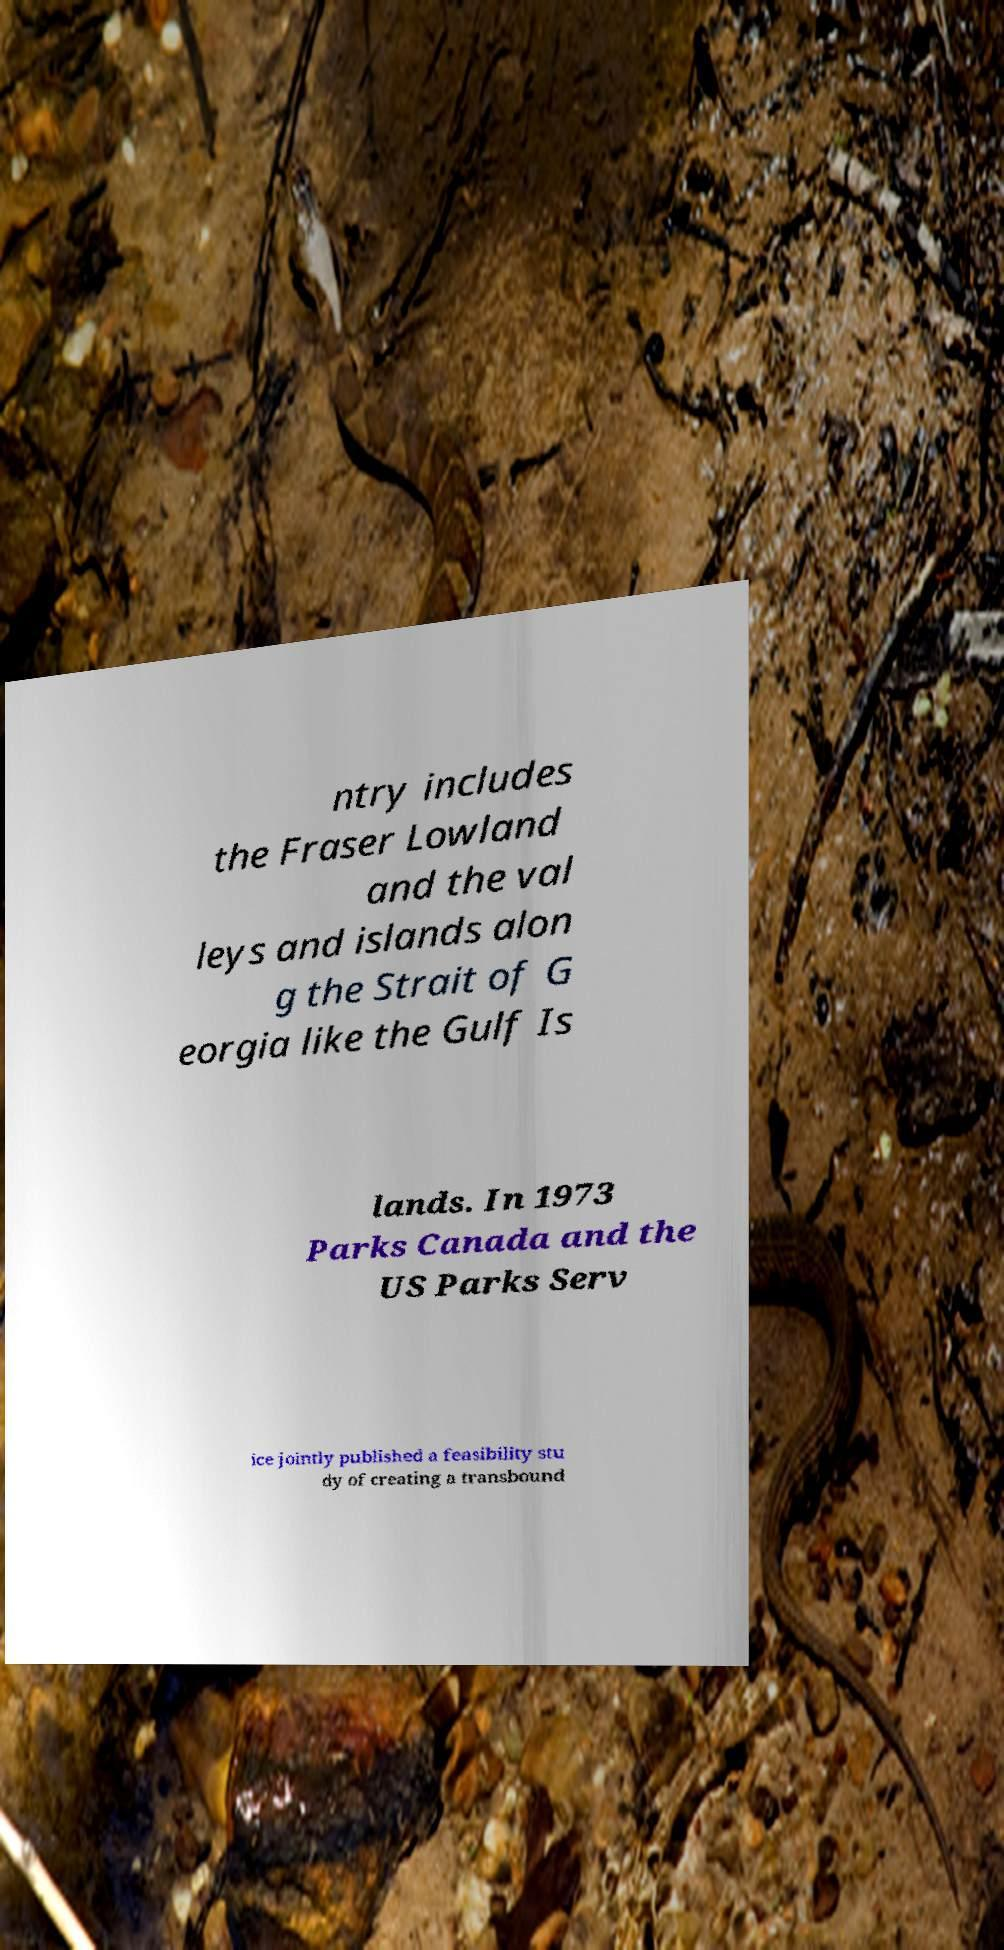There's text embedded in this image that I need extracted. Can you transcribe it verbatim? ntry includes the Fraser Lowland and the val leys and islands alon g the Strait of G eorgia like the Gulf Is lands. In 1973 Parks Canada and the US Parks Serv ice jointly published a feasibility stu dy of creating a transbound 